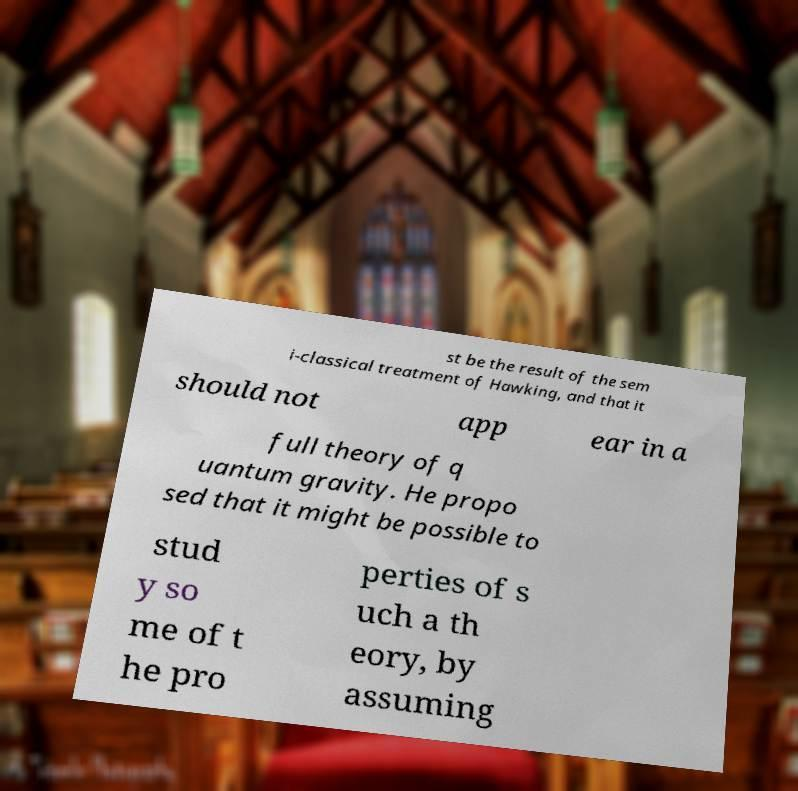Can you read and provide the text displayed in the image?This photo seems to have some interesting text. Can you extract and type it out for me? st be the result of the sem i-classical treatment of Hawking, and that it should not app ear in a full theory of q uantum gravity. He propo sed that it might be possible to stud y so me of t he pro perties of s uch a th eory, by assuming 